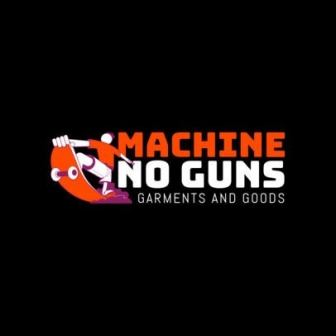Why do you think the company chose this design for their logo? The design is likely chosen to clearly and strongly communicate the company's message against gun use. The use of bright, contrasting colors helps to grab attention, and the universal symbol of a red circle with a slash ensures the message is understood quickly. This design also helps the company stand out by aligning their visual identity with their core values. 